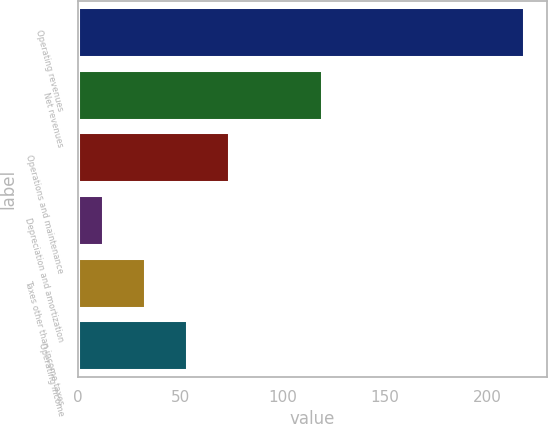Convert chart to OTSL. <chart><loc_0><loc_0><loc_500><loc_500><bar_chart><fcel>Operating revenues<fcel>Net revenues<fcel>Operations and maintenance<fcel>Depreciation and amortization<fcel>Taxes other than income taxes<fcel>Operating income<nl><fcel>218<fcel>119<fcel>73.8<fcel>12<fcel>32.6<fcel>53.2<nl></chart> 